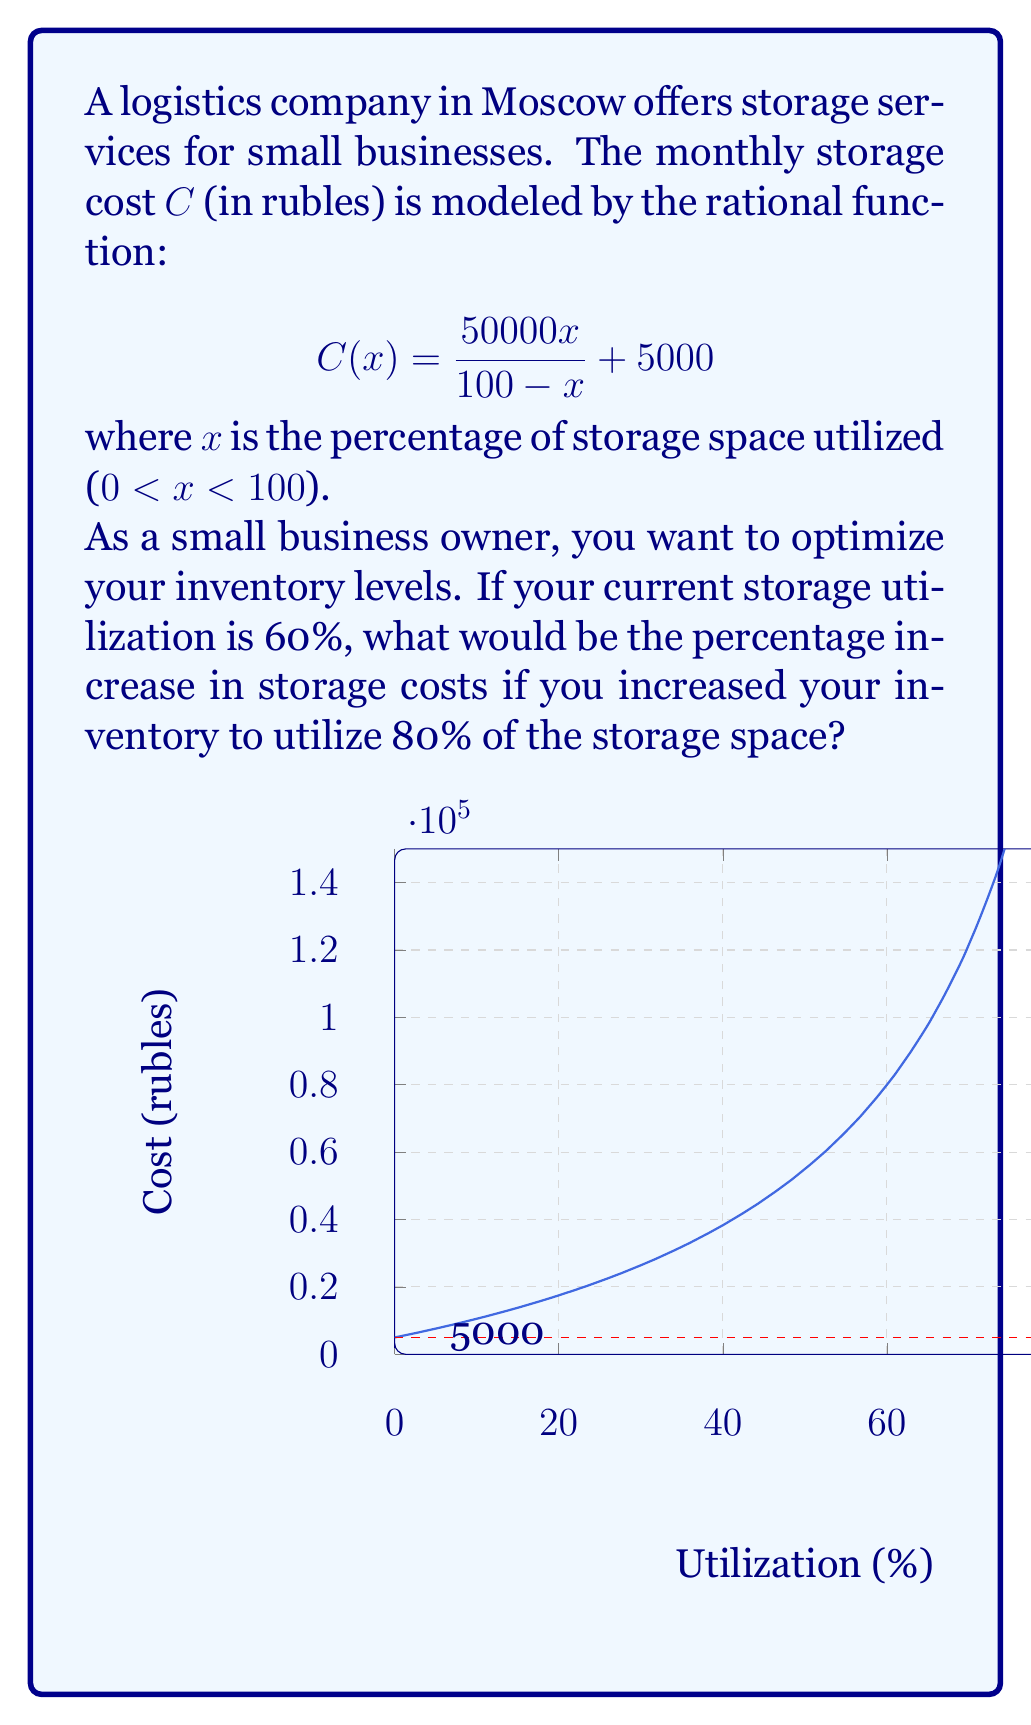Give your solution to this math problem. Let's approach this step-by-step:

1) First, we need to calculate the cost at 60% utilization:
   $$C(60) = \frac{50000(60)}{100 - 60} + 5000 = \frac{3000000}{40} + 5000 = 75000 + 5000 = 80000\text{ rubles}$$

2) Next, we calculate the cost at 80% utilization:
   $$C(80) = \frac{50000(80)}{100 - 80} + 5000 = \frac{4000000}{20} + 5000 = 200000 + 5000 = 205000\text{ rubles}$$

3) To find the percentage increase, we use the formula:
   $$\text{Percentage Increase} = \frac{\text{Increase}}{\text{Original}} \times 100\%$$

4) The increase in cost is:
   $$205000 - 80000 = 125000\text{ rubles}$$

5) Now we can calculate the percentage increase:
   $$\text{Percentage Increase} = \frac{125000}{80000} \times 100\% = 1.5625 \times 100\% = 156.25\%$$

Therefore, increasing the storage utilization from 60% to 80% would result in a 156.25% increase in storage costs.
Answer: 156.25% 